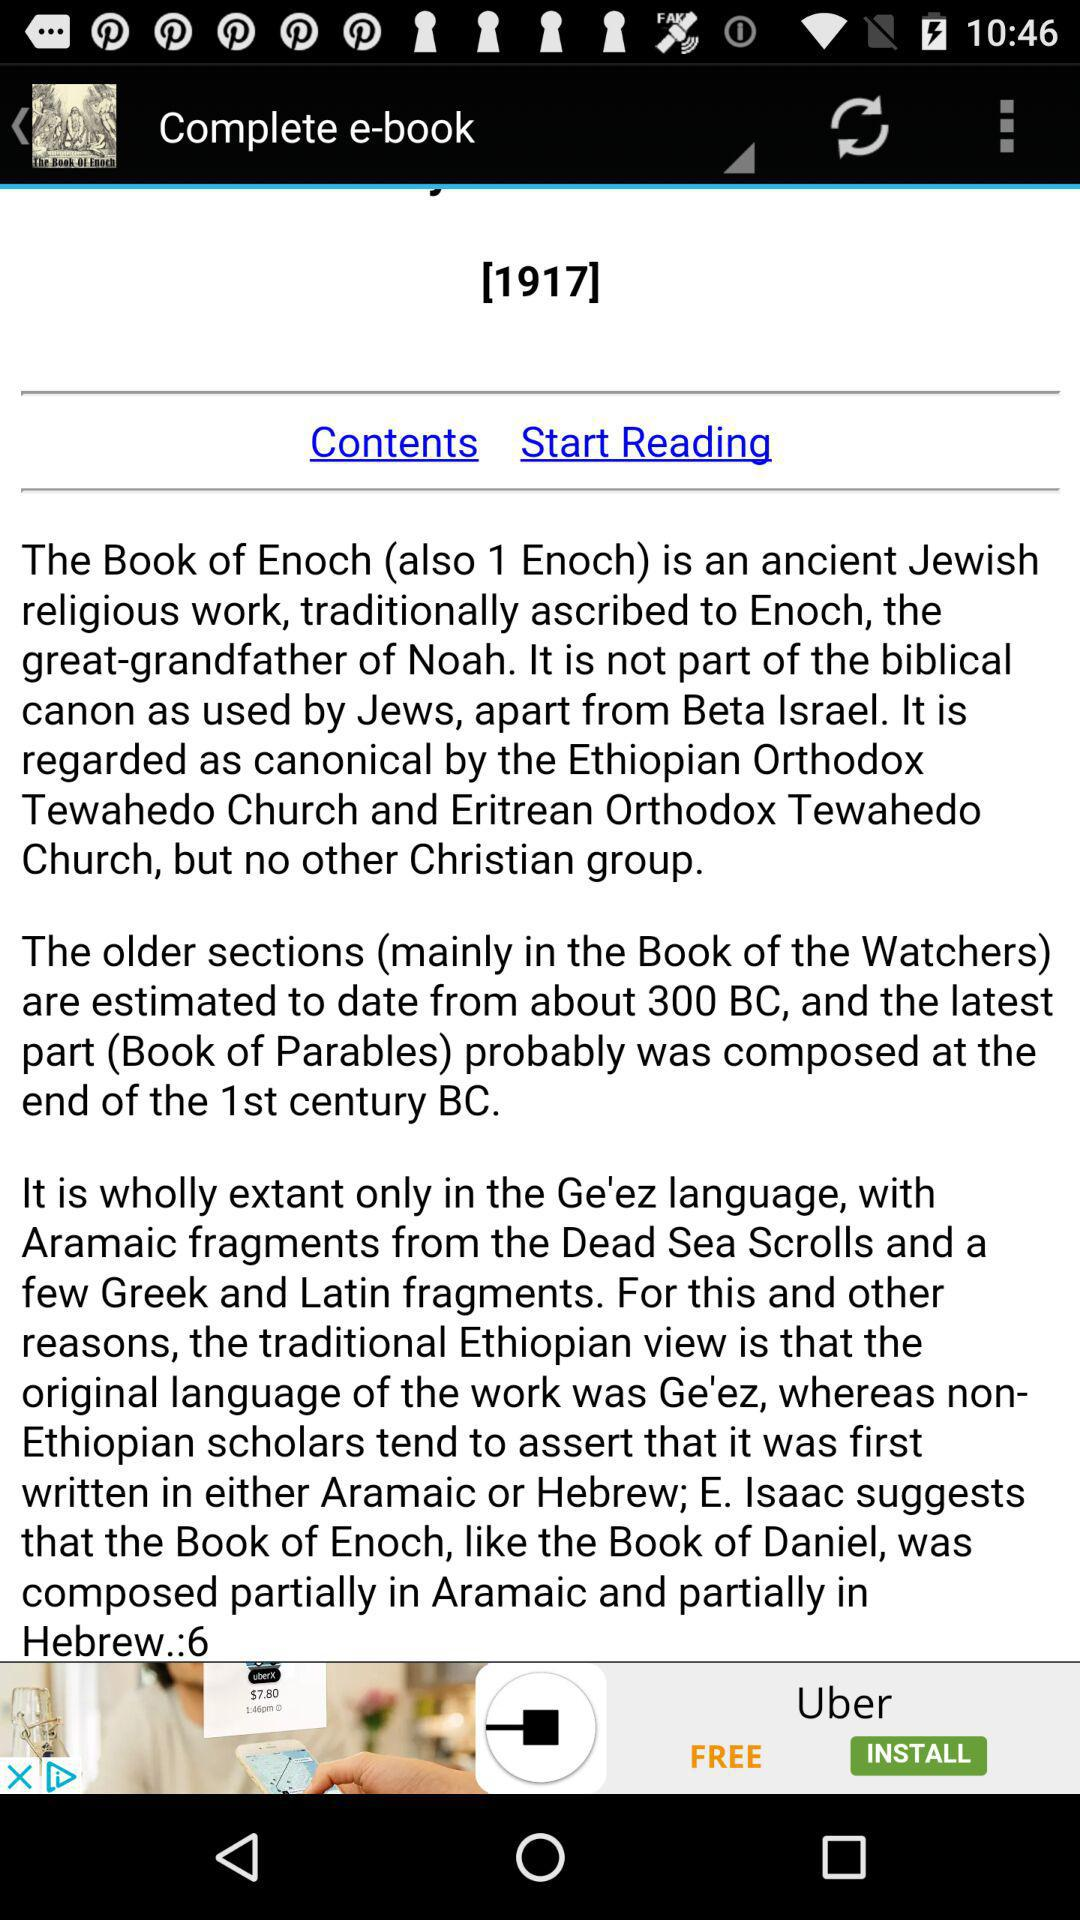What is the name of the application? The name of the application is "The Book of Enoch". 